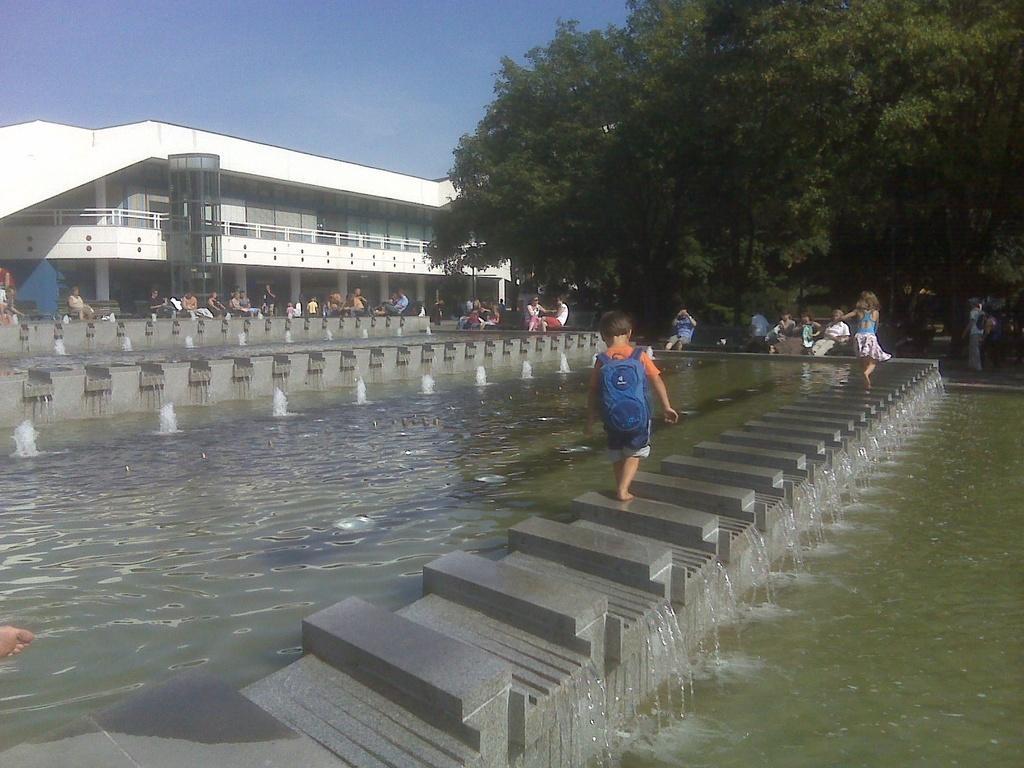Describe this image in one or two sentences. In this picture I can see a water fall, in the middle a boy is walking through this wall, he wore bag. On the left side there is a building and few people are sitting and standing, on the right side there are green trees in this image. 